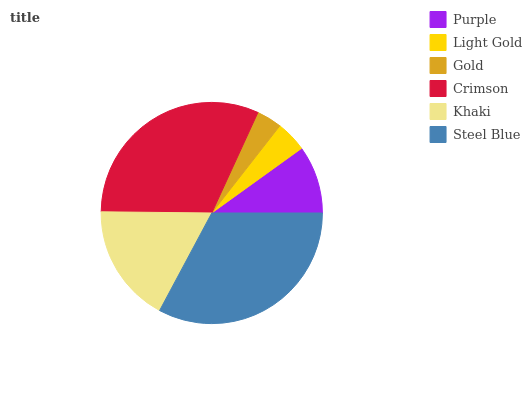Is Gold the minimum?
Answer yes or no. Yes. Is Steel Blue the maximum?
Answer yes or no. Yes. Is Light Gold the minimum?
Answer yes or no. No. Is Light Gold the maximum?
Answer yes or no. No. Is Purple greater than Light Gold?
Answer yes or no. Yes. Is Light Gold less than Purple?
Answer yes or no. Yes. Is Light Gold greater than Purple?
Answer yes or no. No. Is Purple less than Light Gold?
Answer yes or no. No. Is Khaki the high median?
Answer yes or no. Yes. Is Purple the low median?
Answer yes or no. Yes. Is Gold the high median?
Answer yes or no. No. Is Light Gold the low median?
Answer yes or no. No. 